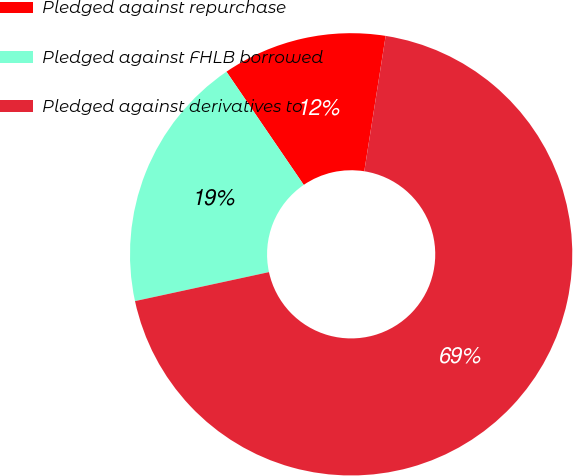<chart> <loc_0><loc_0><loc_500><loc_500><pie_chart><fcel>Pledged against repurchase<fcel>Pledged against FHLB borrowed<fcel>Pledged against derivatives to<nl><fcel>12.03%<fcel>18.86%<fcel>69.12%<nl></chart> 